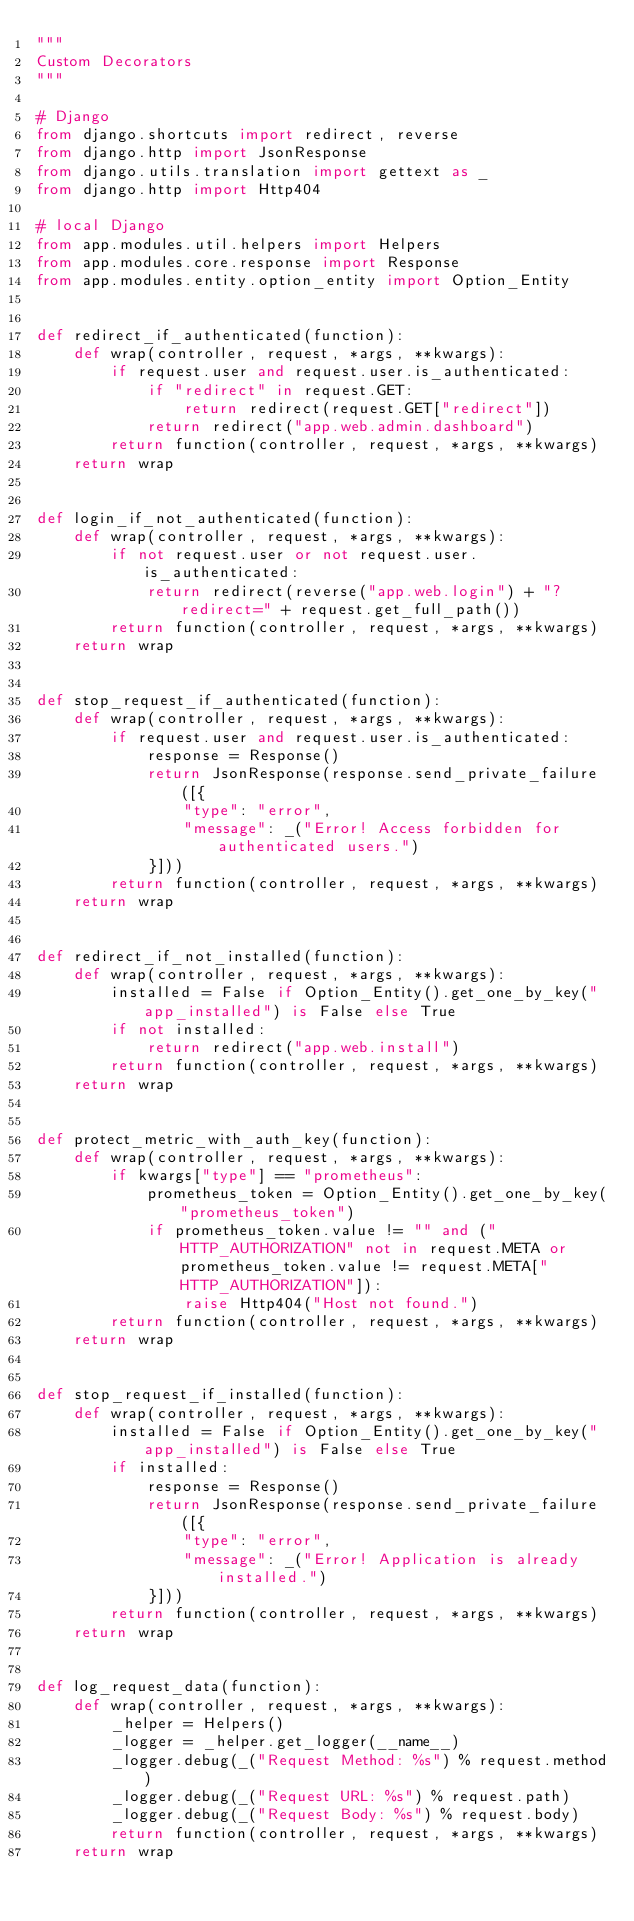Convert code to text. <code><loc_0><loc_0><loc_500><loc_500><_Python_>"""
Custom Decorators
"""

# Django
from django.shortcuts import redirect, reverse
from django.http import JsonResponse
from django.utils.translation import gettext as _
from django.http import Http404

# local Django
from app.modules.util.helpers import Helpers
from app.modules.core.response import Response
from app.modules.entity.option_entity import Option_Entity


def redirect_if_authenticated(function):
    def wrap(controller, request, *args, **kwargs):
        if request.user and request.user.is_authenticated:
            if "redirect" in request.GET:
                return redirect(request.GET["redirect"])
            return redirect("app.web.admin.dashboard")
        return function(controller, request, *args, **kwargs)
    return wrap


def login_if_not_authenticated(function):
    def wrap(controller, request, *args, **kwargs):
        if not request.user or not request.user.is_authenticated:
            return redirect(reverse("app.web.login") + "?redirect=" + request.get_full_path())
        return function(controller, request, *args, **kwargs)
    return wrap


def stop_request_if_authenticated(function):
    def wrap(controller, request, *args, **kwargs):
        if request.user and request.user.is_authenticated:
            response = Response()
            return JsonResponse(response.send_private_failure([{
                "type": "error",
                "message": _("Error! Access forbidden for authenticated users.")
            }]))
        return function(controller, request, *args, **kwargs)
    return wrap


def redirect_if_not_installed(function):
    def wrap(controller, request, *args, **kwargs):
        installed = False if Option_Entity().get_one_by_key("app_installed") is False else True
        if not installed:
            return redirect("app.web.install")
        return function(controller, request, *args, **kwargs)
    return wrap


def protect_metric_with_auth_key(function):
    def wrap(controller, request, *args, **kwargs):
        if kwargs["type"] == "prometheus":
            prometheus_token = Option_Entity().get_one_by_key("prometheus_token")
            if prometheus_token.value != "" and ("HTTP_AUTHORIZATION" not in request.META or prometheus_token.value != request.META["HTTP_AUTHORIZATION"]):
                raise Http404("Host not found.")
        return function(controller, request, *args, **kwargs)
    return wrap


def stop_request_if_installed(function):
    def wrap(controller, request, *args, **kwargs):
        installed = False if Option_Entity().get_one_by_key("app_installed") is False else True
        if installed:
            response = Response()
            return JsonResponse(response.send_private_failure([{
                "type": "error",
                "message": _("Error! Application is already installed.")
            }]))
        return function(controller, request, *args, **kwargs)
    return wrap


def log_request_data(function):
    def wrap(controller, request, *args, **kwargs):
        _helper = Helpers()
        _logger = _helper.get_logger(__name__)
        _logger.debug(_("Request Method: %s") % request.method)
        _logger.debug(_("Request URL: %s") % request.path)
        _logger.debug(_("Request Body: %s") % request.body)
        return function(controller, request, *args, **kwargs)
    return wrap
</code> 